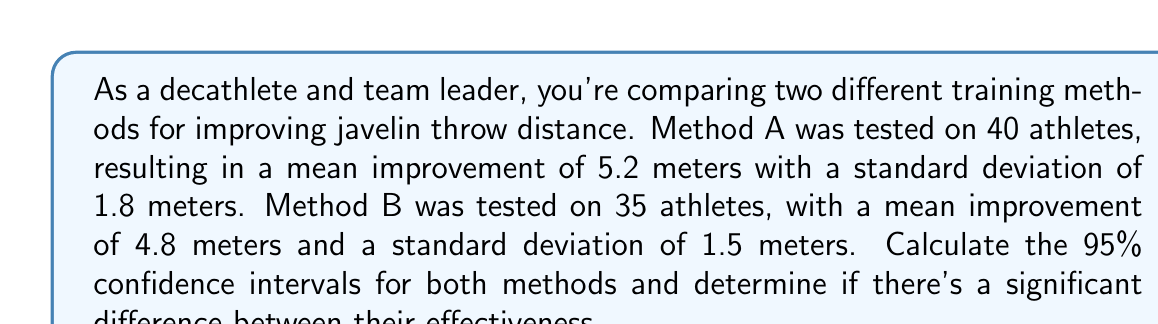Can you solve this math problem? Let's approach this step-by-step:

1) The formula for the confidence interval is:

   $$ \text{CI} = \bar{x} \pm t_{\alpha/2} \cdot \frac{s}{\sqrt{n}} $$

   where $\bar{x}$ is the sample mean, $s$ is the sample standard deviation, $n$ is the sample size, and $t_{\alpha/2}$ is the t-value for a 95% confidence level.

2) For a 95% confidence level with large samples (n > 30), we can use z-score of 1.96 instead of t-value.

3) For Method A:
   $n_A = 40$, $\bar{x}_A = 5.2$, $s_A = 1.8$

   $$ \text{CI}_A = 5.2 \pm 1.96 \cdot \frac{1.8}{\sqrt{40}} $$
   $$ = 5.2 \pm 1.96 \cdot 0.2846 $$
   $$ = 5.2 \pm 0.5578 $$
   $$ = (4.6422, 5.7578) $$

4) For Method B:
   $n_B = 35$, $\bar{x}_B = 4.8$, $s_B = 1.5$

   $$ \text{CI}_B = 4.8 \pm 1.96 \cdot \frac{1.5}{\sqrt{35}} $$
   $$ = 4.8 \pm 1.96 \cdot 0.2535 $$
   $$ = 4.8 \pm 0.4969 $$
   $$ = (4.3031, 5.2969) $$

5) To determine if there's a significant difference, we check if the confidence intervals overlap. In this case, they do overlap, which suggests that there isn't strong evidence of a significant difference between the two methods at the 95% confidence level.
Answer: Method A CI: (4.6422, 5.7578)
Method B CI: (4.3031, 5.2969)
No significant difference (CIs overlap) 